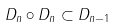Convert formula to latex. <formula><loc_0><loc_0><loc_500><loc_500>D _ { n } \circ D _ { n } \subset D _ { n - 1 }</formula> 